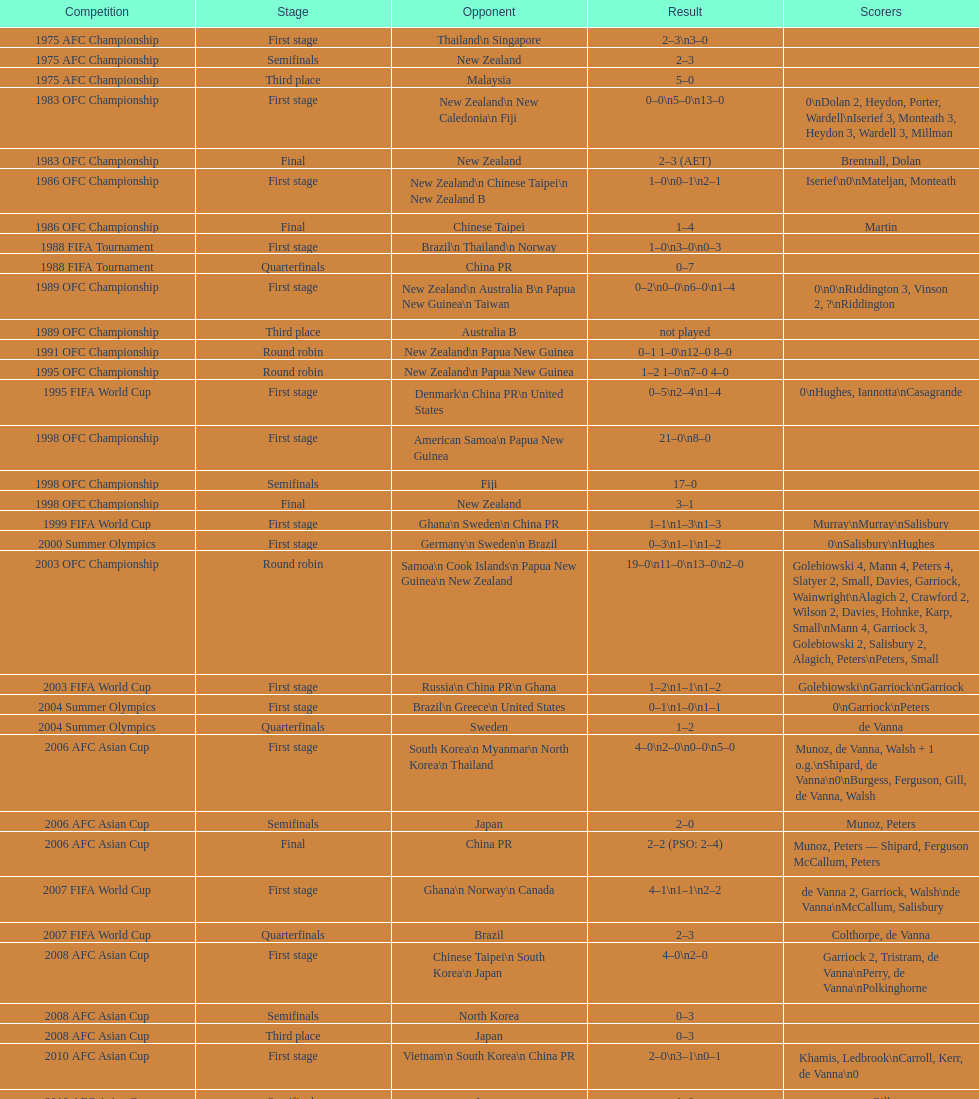In the final round of the 2012 summer olympics afc qualification, what was the total number of points scored? 12. 